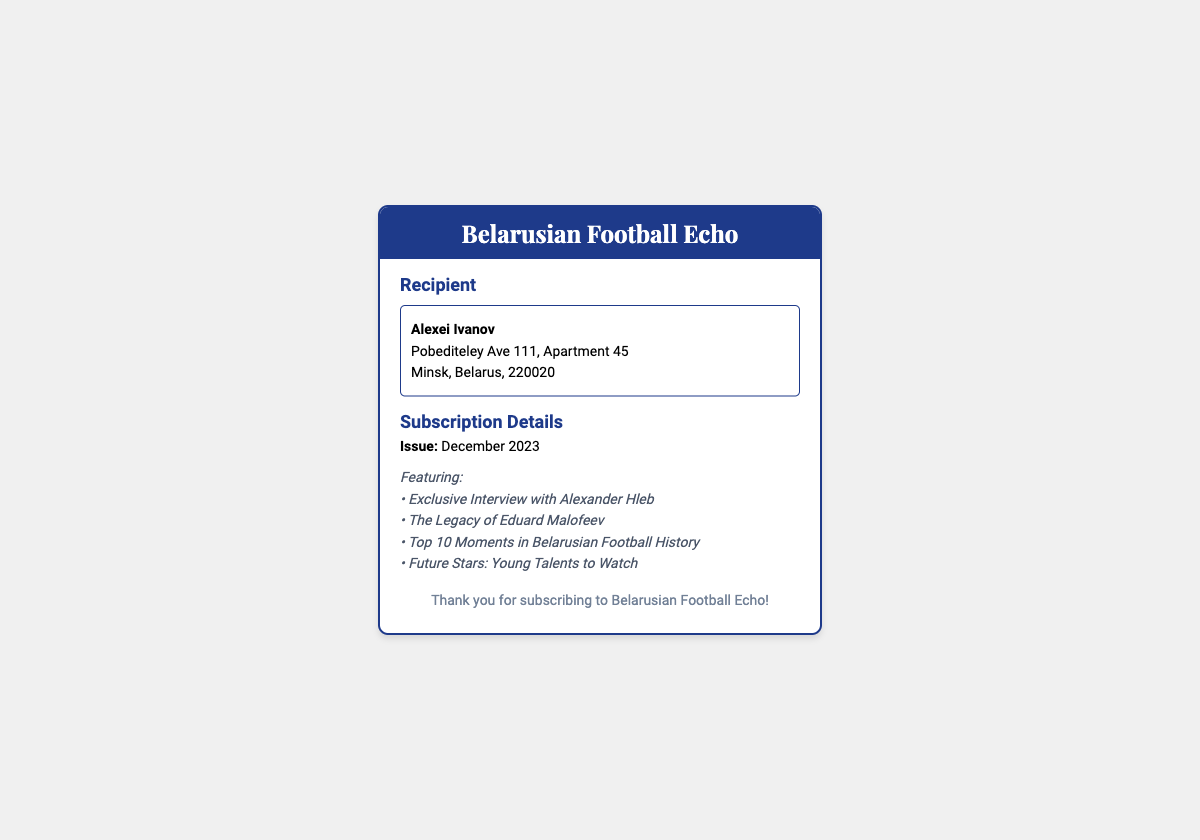What is the recipient's name? The recipient's name is mentioned in the address section of the document.
Answer: Alexei Ivanov What is the subscription issue date? The issue date of the magazine is listed under Subscription Details.
Answer: December 2023 Who is featured in the exclusive interview? The document highlights the exclusive interview featured in the magazine.
Answer: Alexander Hleb What is the address of the recipient? The complete address for the recipient is found in the address section.
Answer: Pobediteley Ave 111, Apartment 45, Minsk, Belarus, 220020 What is the title of the magazine? The title is presented in the header of the shipping label.
Answer: Belarusian Football Echo What is one of the top moments included in the magazine? The document lists specific moments as part of the content summary.
Answer: Top 10 Moments in Belarusian Football History How many features are listed in the content summary? By counting the features listed under the content summary, we obtain the total number of features.
Answer: Four 